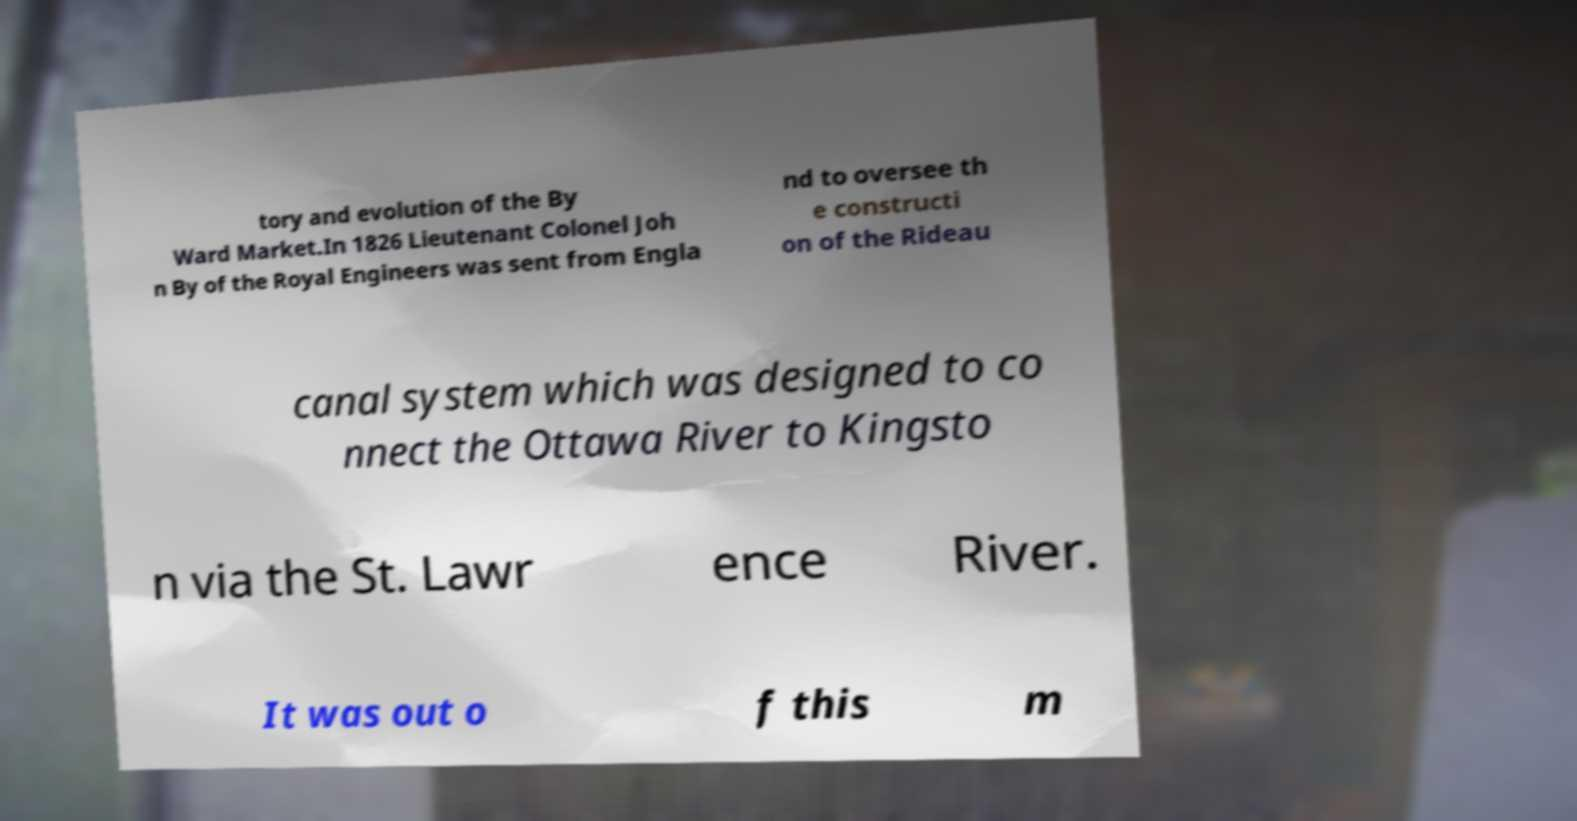Could you assist in decoding the text presented in this image and type it out clearly? tory and evolution of the By Ward Market.In 1826 Lieutenant Colonel Joh n By of the Royal Engineers was sent from Engla nd to oversee th e constructi on of the Rideau canal system which was designed to co nnect the Ottawa River to Kingsto n via the St. Lawr ence River. It was out o f this m 